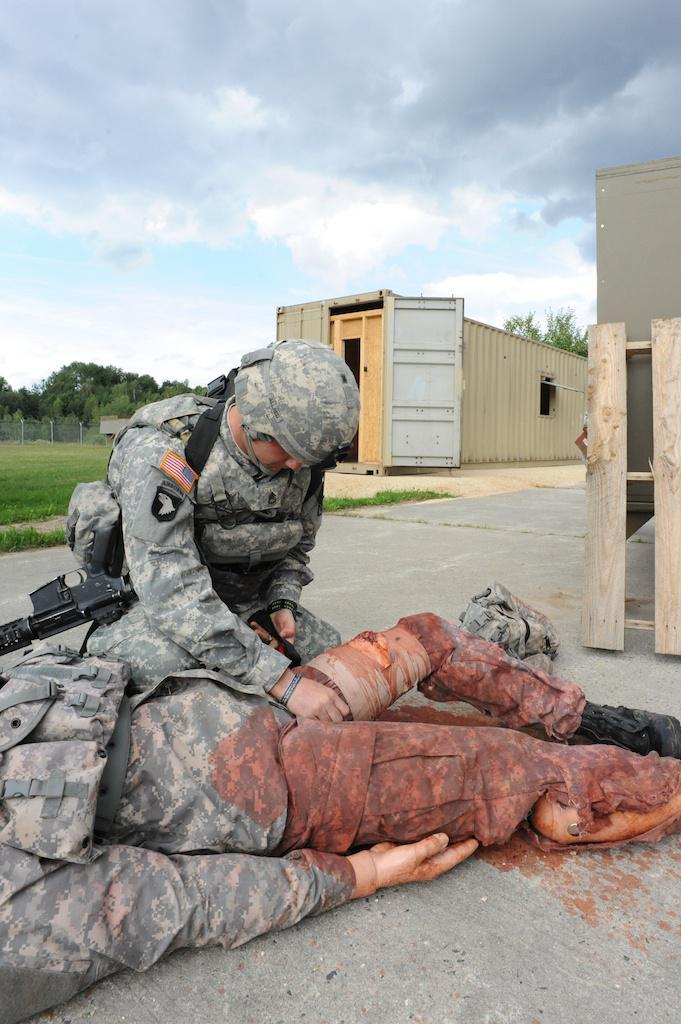What are the two people in the foreground of the image wearing? The two people in the foreground of the image are wearing military uniforms. What can be seen in the background of the image? In the background of the image, there are trees, the sky, fencing, and grass. What object can be seen in the image that might be used for storage or transportation? There is a container in the image. How many waves can be seen crashing on the shore in the image? There are no waves or shore visible in the image; it features two people in military uniforms and a background with trees, the sky, fencing, and grass. 